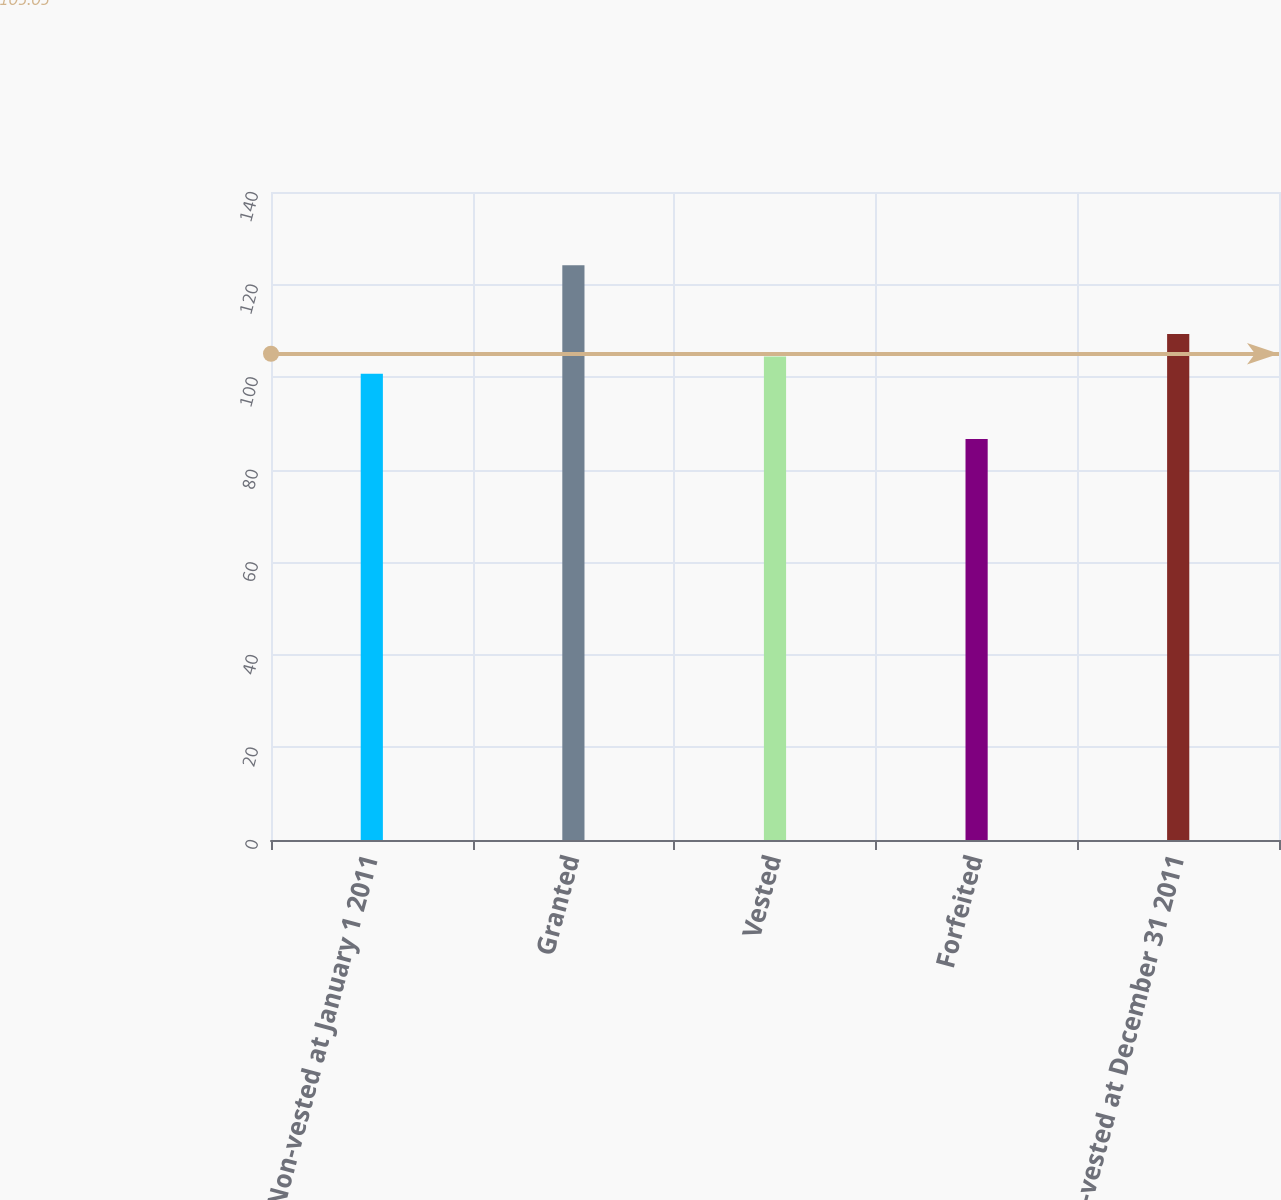<chart> <loc_0><loc_0><loc_500><loc_500><bar_chart><fcel>Non-vested at January 1 2011<fcel>Granted<fcel>Vested<fcel>Forfeited<fcel>Non-vested at December 31 2011<nl><fcel>100.72<fcel>124.16<fcel>104.47<fcel>86.61<fcel>109.31<nl></chart> 